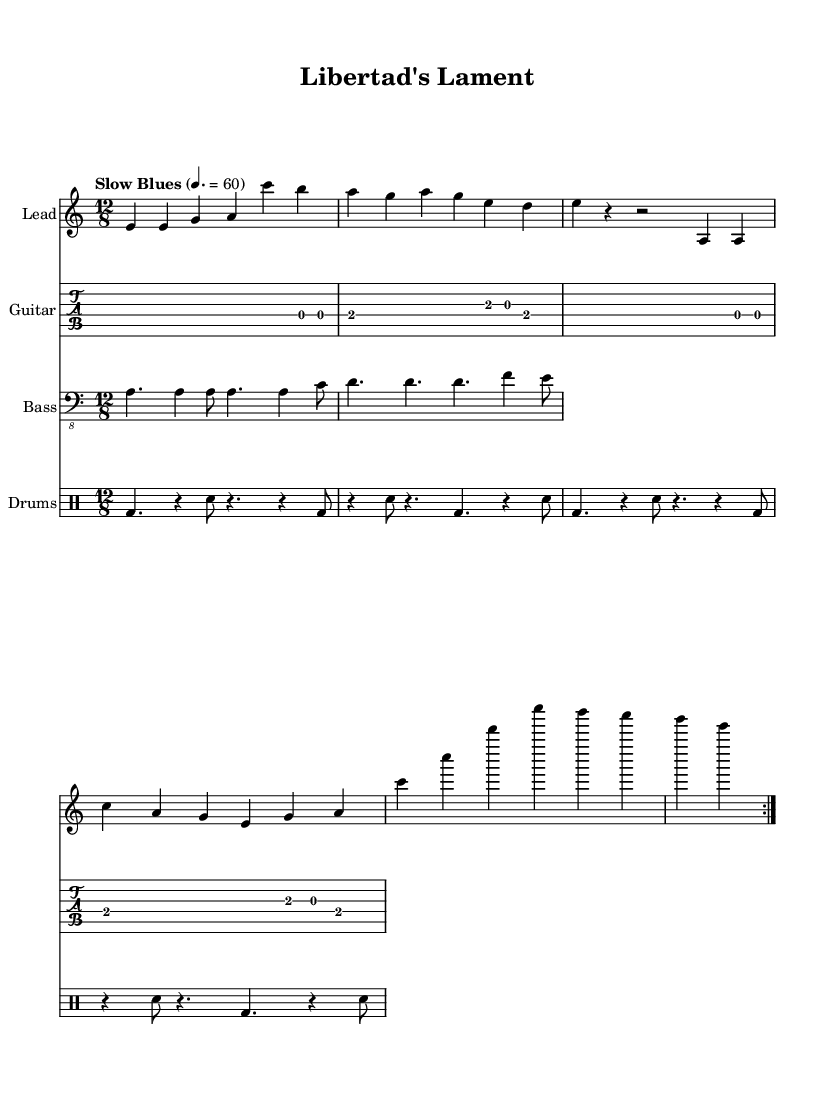What is the key signature of this music? The key signature is A minor, indicated by the presence of one sharp, F#. This can be identified from the key signature notation at the beginning of the staff.
Answer: A minor What is the time signature of this music? The time signature shown in the music is 12/8. This can be inferred from the time signature marking located at the beginning of the piece, which indicates a combination of four beats in a measure, each divided into three eighth notes.
Answer: 12/8 What is the tempo of this piece? The tempo marking indicates "Slow Blues," set at 60 beats per minute. This can be found under the tempo indication at the beginning of the score.
Answer: Slow Blues, 60 How many measures are in the verse? The verse consists of four measures, as counted from the bar lines in the verse section of the score. Each measure contains various rhythms that contribute to the full length of the verse.
Answer: 4 What genre is this piece categorized under? This music is categorized under Electric Blues, which can be inferred from the style of the song, the use of a 12/8 time signature typical in blues music, and the themes present in the lyrics that focus on liberation, a common trait in Blues.
Answer: Electric Blues What is the function of the guitar riff in this piece? The guitar riff serves as a melodic and rhythmic foundation that complements the vocals and maintains the groove typical in Electric Blues songs. Its repetition also aligns with the standard structure of such music, emphasizing the emotional message.
Answer: Melodic and rhythmic foundation 